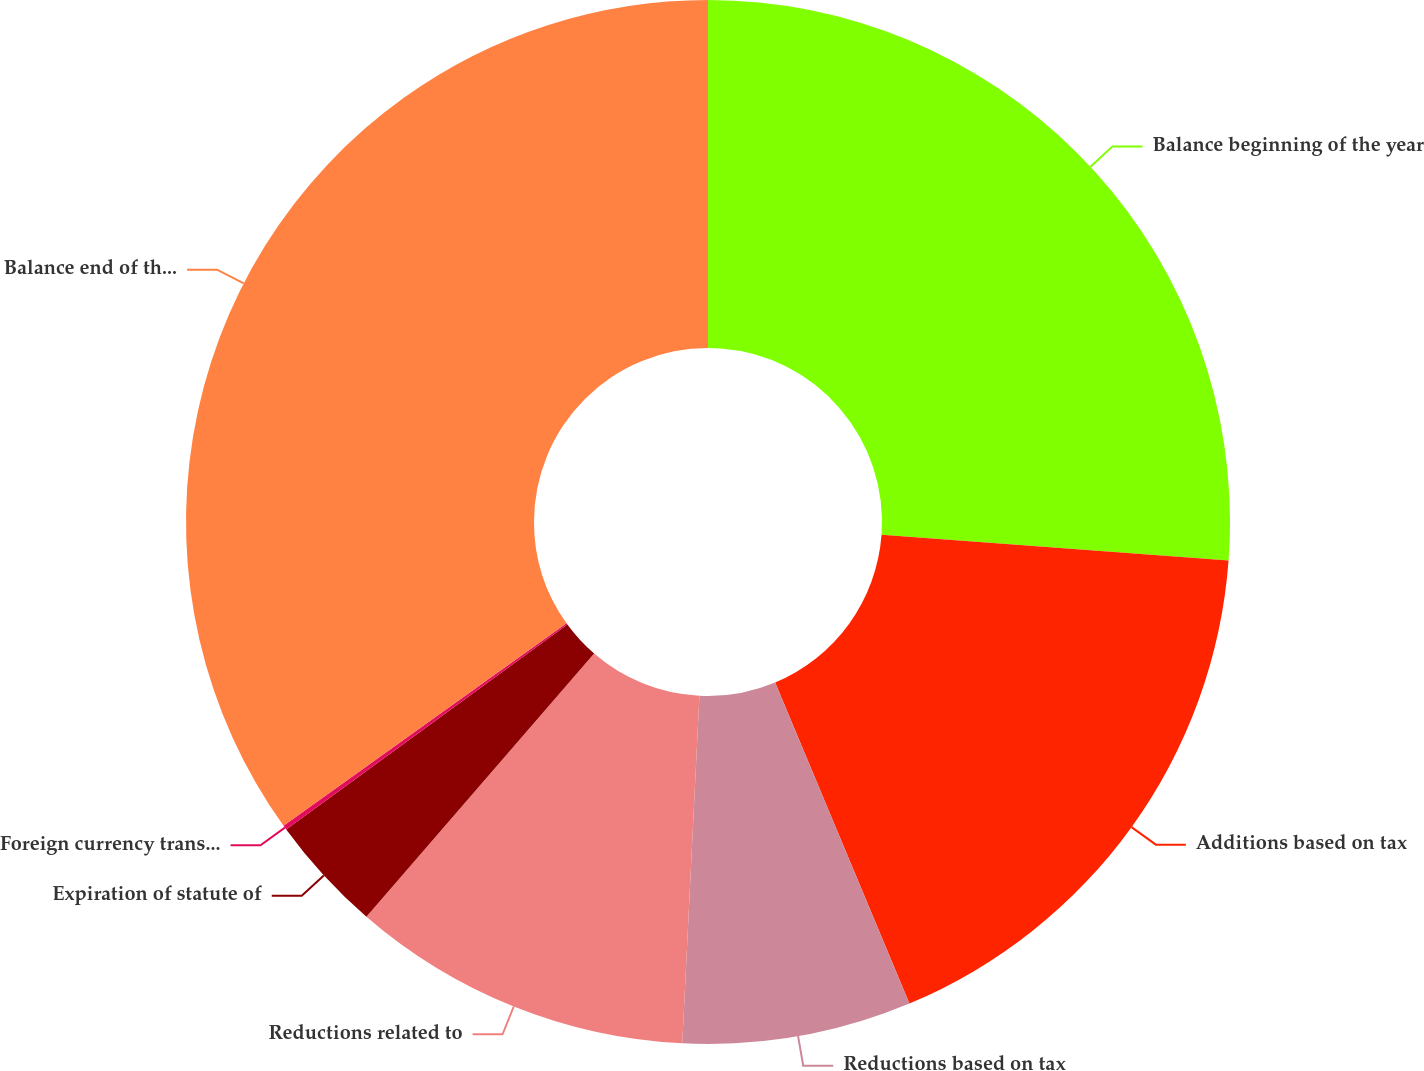Convert chart to OTSL. <chart><loc_0><loc_0><loc_500><loc_500><pie_chart><fcel>Balance beginning of the year<fcel>Additions based on tax<fcel>Reductions based on tax<fcel>Reductions related to<fcel>Expiration of statute of<fcel>Foreign currency translation<fcel>Balance end of the year<nl><fcel>26.18%<fcel>17.52%<fcel>7.09%<fcel>10.57%<fcel>3.62%<fcel>0.14%<fcel>34.89%<nl></chart> 